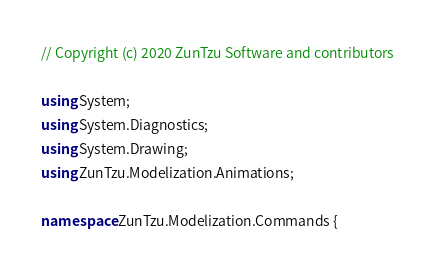Convert code to text. <code><loc_0><loc_0><loc_500><loc_500><_C#_>// Copyright (c) 2020 ZunTzu Software and contributors

using System;
using System.Diagnostics;
using System.Drawing;
using ZunTzu.Modelization.Animations;

namespace ZunTzu.Modelization.Commands {
</code> 